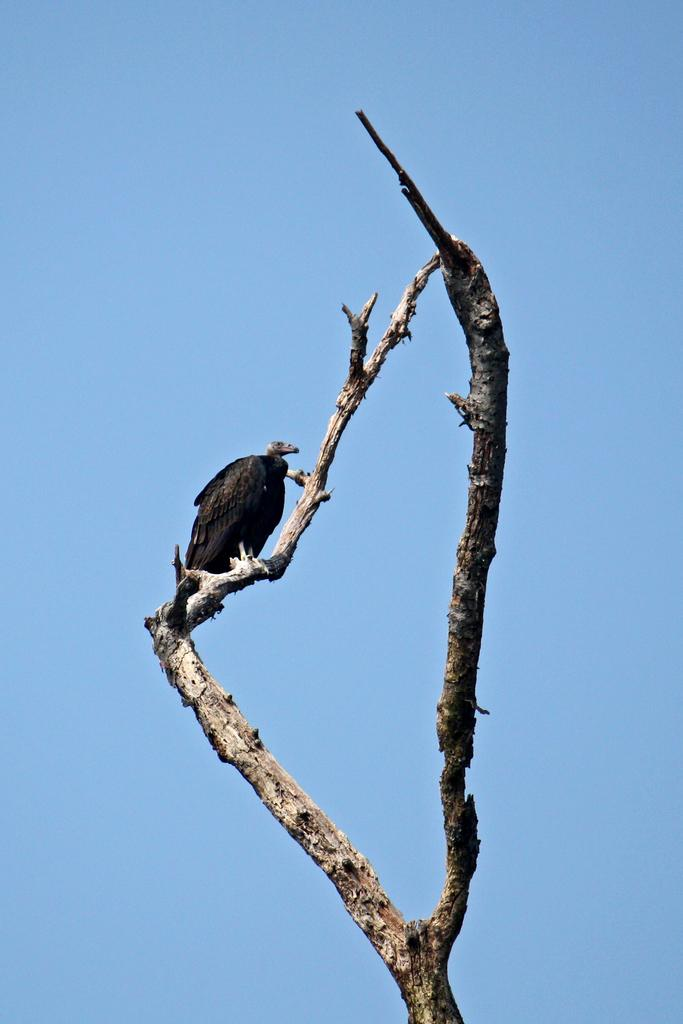What type of animal can be seen in the image? There is a bird in the image. Where is the bird located? The bird is on a tree. What can be seen in the background of the image? There is sky visible in the background of the image. What type of bag is the bird carrying on the stage in the image? There is no bag or stage present in the image; it features a bird on a tree with sky visible in the background. 